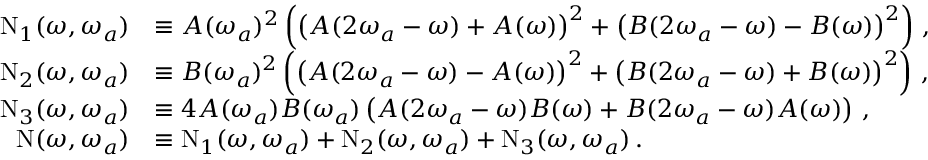<formula> <loc_0><loc_0><loc_500><loc_500>\begin{array} { r l } { N _ { 1 } ( \omega , \omega _ { a } ) } & { \equiv A ( \omega _ { a } ) ^ { 2 } \left ( \left ( A ( 2 \omega _ { a } - \omega ) + A ( \omega ) \right ) ^ { 2 } + \left ( B ( 2 \omega _ { a } - \omega ) - B ( \omega ) \right ) ^ { 2 } \right ) \, , } \\ { N _ { 2 } ( \omega , \omega _ { a } ) } & { \equiv B ( \omega _ { a } ) ^ { 2 } \left ( \left ( A ( 2 \omega _ { a } - \omega ) - A ( \omega ) \right ) ^ { 2 } + \left ( B ( 2 \omega _ { a } - \omega ) + B ( \omega ) \right ) ^ { 2 } \right ) \, , } \\ { N _ { 3 } ( \omega , \omega _ { a } ) } & { \equiv 4 A ( \omega _ { a } ) B ( \omega _ { a } ) \left ( A ( 2 \omega _ { a } - \omega ) B ( \omega ) + B ( 2 \omega _ { a } - \omega ) A ( \omega ) \right ) \, , } \\ { N ( \omega , \omega _ { a } ) } & { \equiv N _ { 1 } ( \omega , \omega _ { a } ) + N _ { 2 } ( \omega , \omega _ { a } ) + N _ { 3 } ( \omega , \omega _ { a } ) \, . } \end{array}</formula> 